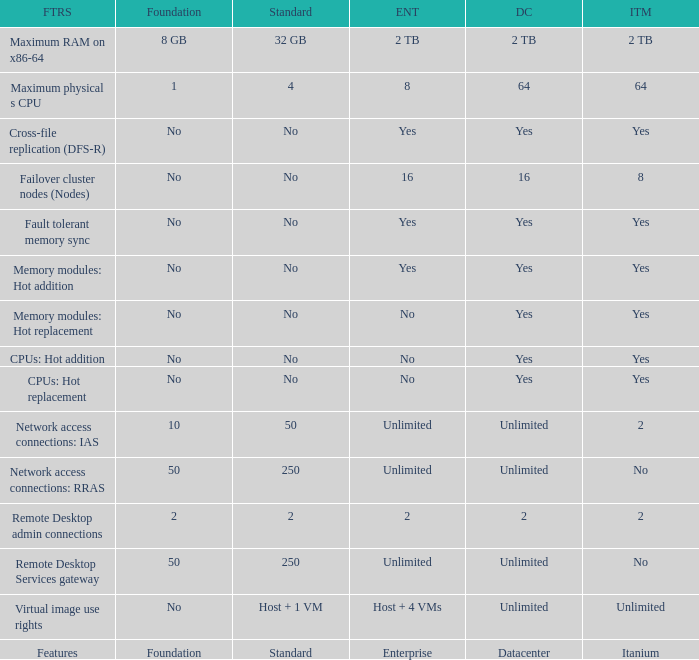What is the Enterprise for teh memory modules: hot replacement Feature that has a Datacenter of Yes? No. 